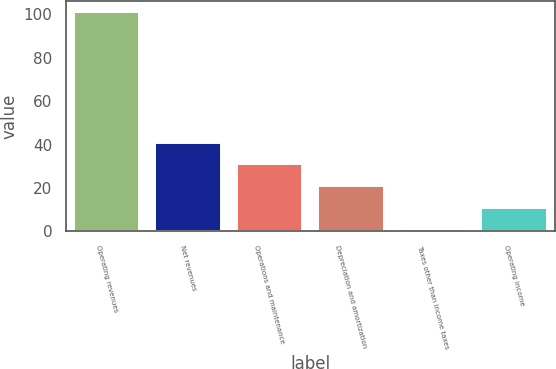<chart> <loc_0><loc_0><loc_500><loc_500><bar_chart><fcel>Operating revenues<fcel>Net revenues<fcel>Operations and maintenance<fcel>Depreciation and amortization<fcel>Taxes other than income taxes<fcel>Operating income<nl><fcel>101<fcel>41<fcel>31<fcel>21<fcel>1<fcel>11<nl></chart> 